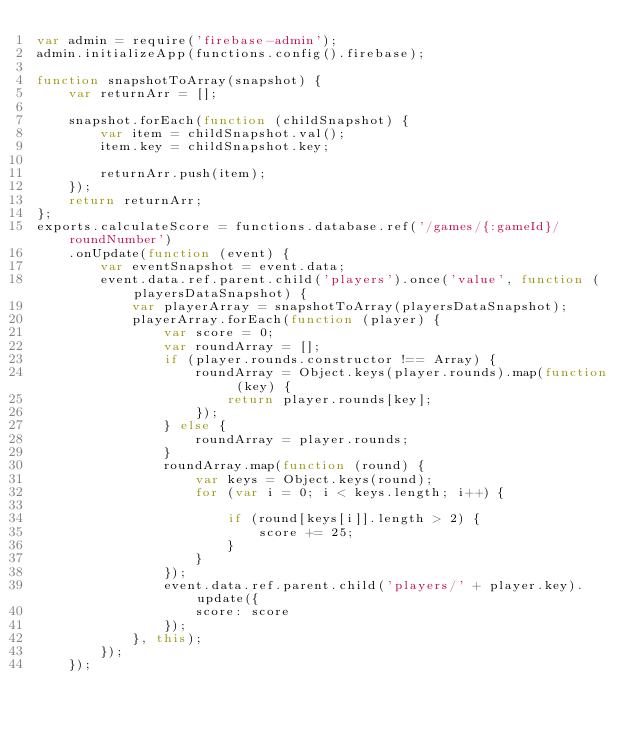<code> <loc_0><loc_0><loc_500><loc_500><_JavaScript_>var admin = require('firebase-admin');
admin.initializeApp(functions.config().firebase);

function snapshotToArray(snapshot) {
    var returnArr = [];

    snapshot.forEach(function (childSnapshot) {
        var item = childSnapshot.val();
        item.key = childSnapshot.key;

        returnArr.push(item);
    });
    return returnArr;
};
exports.calculateScore = functions.database.ref('/games/{:gameId}/roundNumber')
    .onUpdate(function (event) {
        var eventSnapshot = event.data;
        event.data.ref.parent.child('players').once('value', function (playersDataSnapshot) {
            var playerArray = snapshotToArray(playersDataSnapshot);
            playerArray.forEach(function (player) {
                var score = 0;
                var roundArray = [];
                if (player.rounds.constructor !== Array) {
                    roundArray = Object.keys(player.rounds).map(function (key) {
                        return player.rounds[key];
                    });
                } else {
                    roundArray = player.rounds;
                }
                roundArray.map(function (round) {
                    var keys = Object.keys(round);
                    for (var i = 0; i < keys.length; i++) {

                        if (round[keys[i]].length > 2) {
                            score += 25;
                        }
                    }
                });
                event.data.ref.parent.child('players/' + player.key).update({
                    score: score
                });
            }, this);
        });
    });</code> 